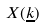Convert formula to latex. <formula><loc_0><loc_0><loc_500><loc_500>X ( \underline { k } )</formula> 